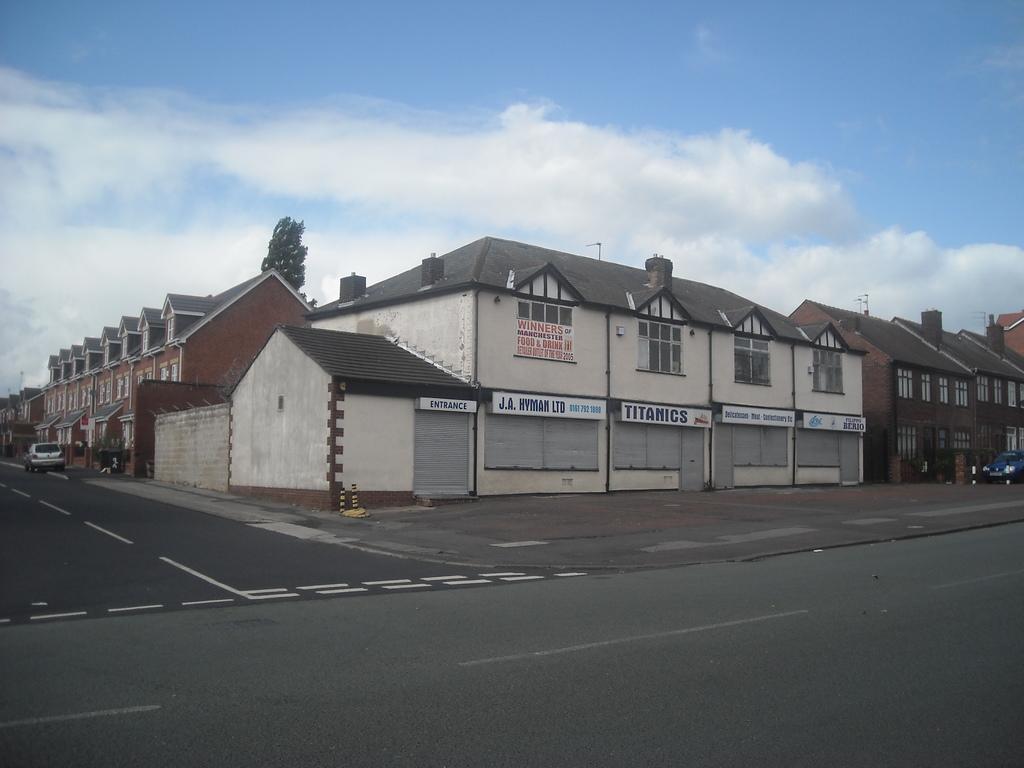In one or two sentences, can you explain what this image depicts? This image is taken outdoors. At the top of the image there is the sky with clouds. At the bottom of the image there is a road. In the middle of the image there are many buildings with walls, windows, doors and roofs. There are a few boards with text on them. There is a tree. There are a few poles. On the left side of the image a car is parked on the road. On the right side of the image a car is parked on the road. 